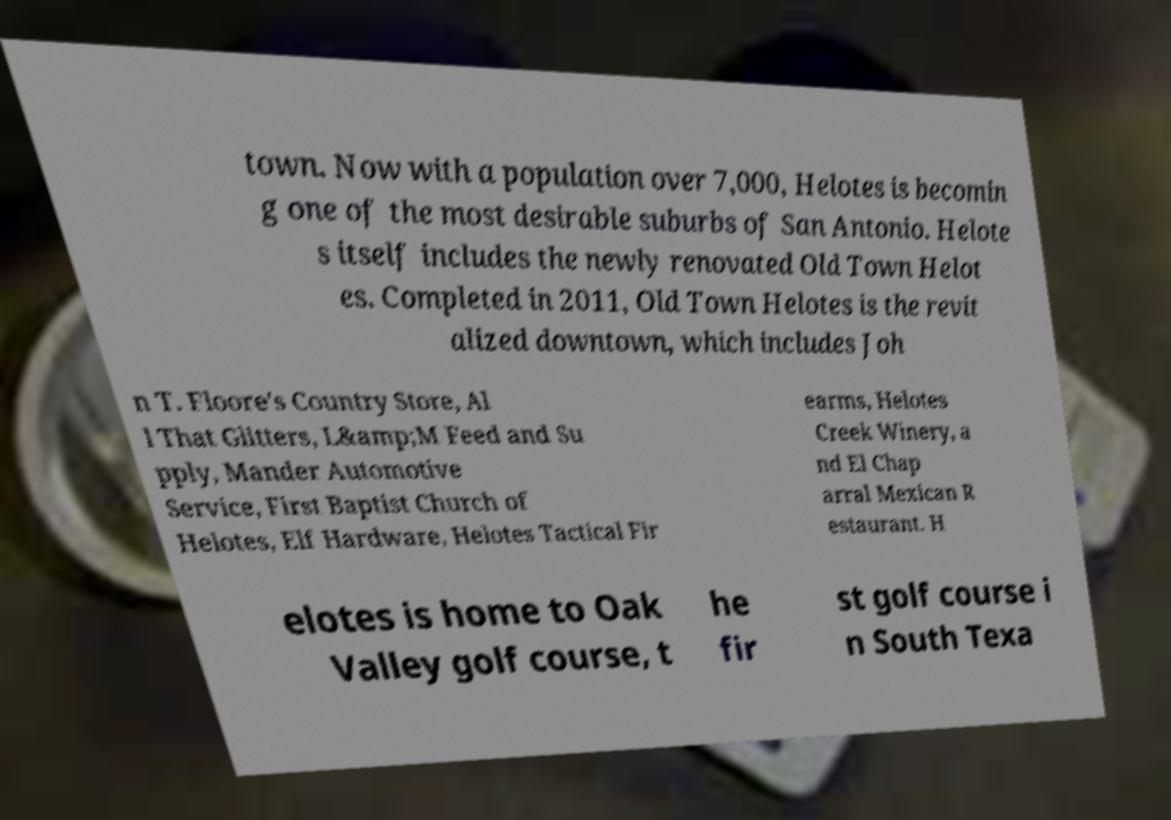There's text embedded in this image that I need extracted. Can you transcribe it verbatim? town. Now with a population over 7,000, Helotes is becomin g one of the most desirable suburbs of San Antonio. Helote s itself includes the newly renovated Old Town Helot es. Completed in 2011, Old Town Helotes is the revit alized downtown, which includes Joh n T. Floore's Country Store, Al l That Glitters, L&amp;M Feed and Su pply, Mander Automotive Service, First Baptist Church of Helotes, Elf Hardware, Helotes Tactical Fir earms, Helotes Creek Winery, a nd El Chap arral Mexican R estaurant. H elotes is home to Oak Valley golf course, t he fir st golf course i n South Texa 